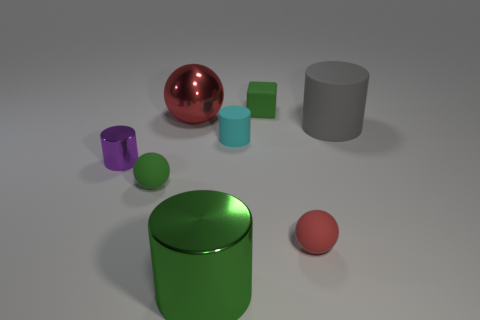There is another sphere that is the same color as the big shiny sphere; what is it made of?
Your answer should be very brief. Rubber. The cyan matte thing has what shape?
Ensure brevity in your answer.  Cylinder. Is the number of green things in front of the green metallic cylinder greater than the number of big red cylinders?
Ensure brevity in your answer.  No. There is a big shiny thing that is behind the large gray matte cylinder; what shape is it?
Keep it short and to the point. Sphere. What number of other things are there of the same shape as the purple metallic object?
Ensure brevity in your answer.  3. Does the green thing behind the big gray cylinder have the same material as the large gray cylinder?
Give a very brief answer. Yes. Are there the same number of tiny cyan rubber cylinders that are behind the small green matte cube and tiny metallic objects on the right side of the green metal cylinder?
Offer a very short reply. Yes. There is a matte cylinder that is to the left of the large gray matte thing; what size is it?
Provide a succinct answer. Small. Are there any large objects that have the same material as the tiny green ball?
Offer a terse response. Yes. Is the color of the sphere that is right of the rubber cube the same as the cube?
Offer a very short reply. No. 